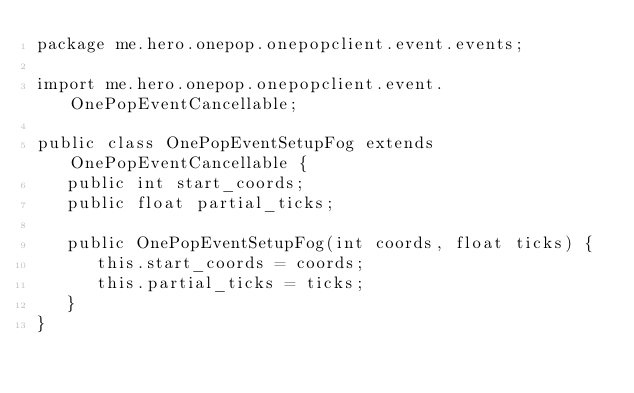<code> <loc_0><loc_0><loc_500><loc_500><_Java_>package me.hero.onepop.onepopclient.event.events;

import me.hero.onepop.onepopclient.event.OnePopEventCancellable;

public class OnePopEventSetupFog extends OnePopEventCancellable {
   public int start_coords;
   public float partial_ticks;

   public OnePopEventSetupFog(int coords, float ticks) {
      this.start_coords = coords;
      this.partial_ticks = ticks;
   }
}
</code> 